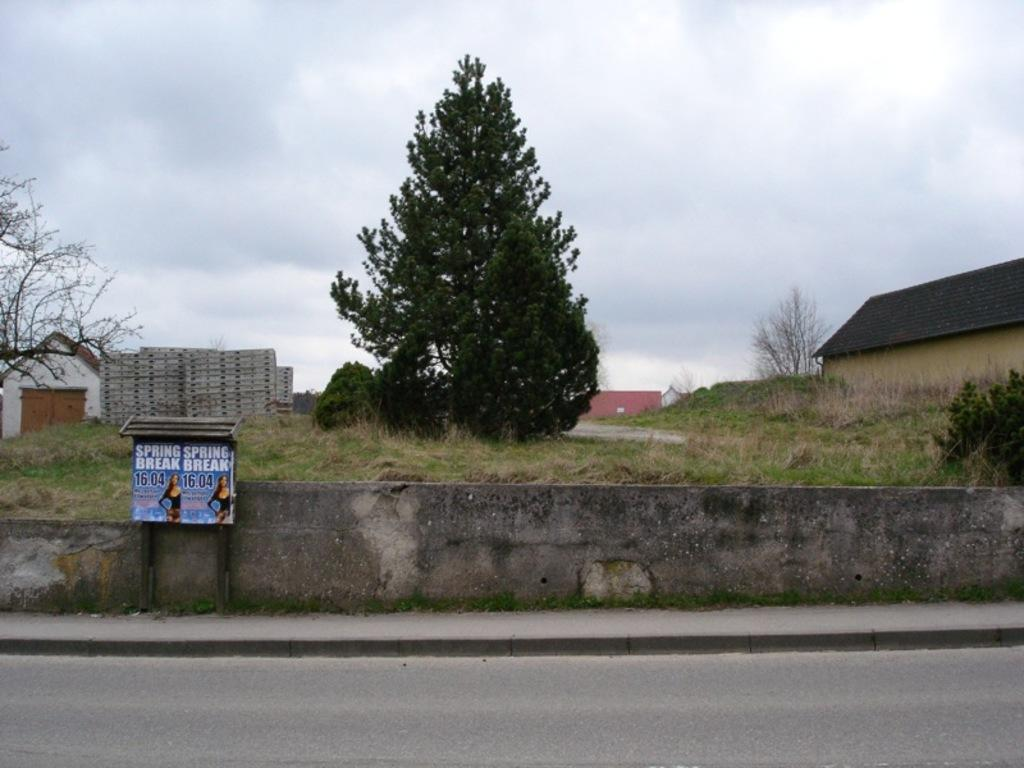What is the main object in the image? There is a board in the image. What can be seen in the background of the image? There is a wall from left to right, grass, buildings, trees, and a cloudy sky visible in the image. How many clovers can be seen growing on the board in the image? There are no clovers present in the image, as it features a board, a wall, grass, buildings, trees, and a cloudy sky. 